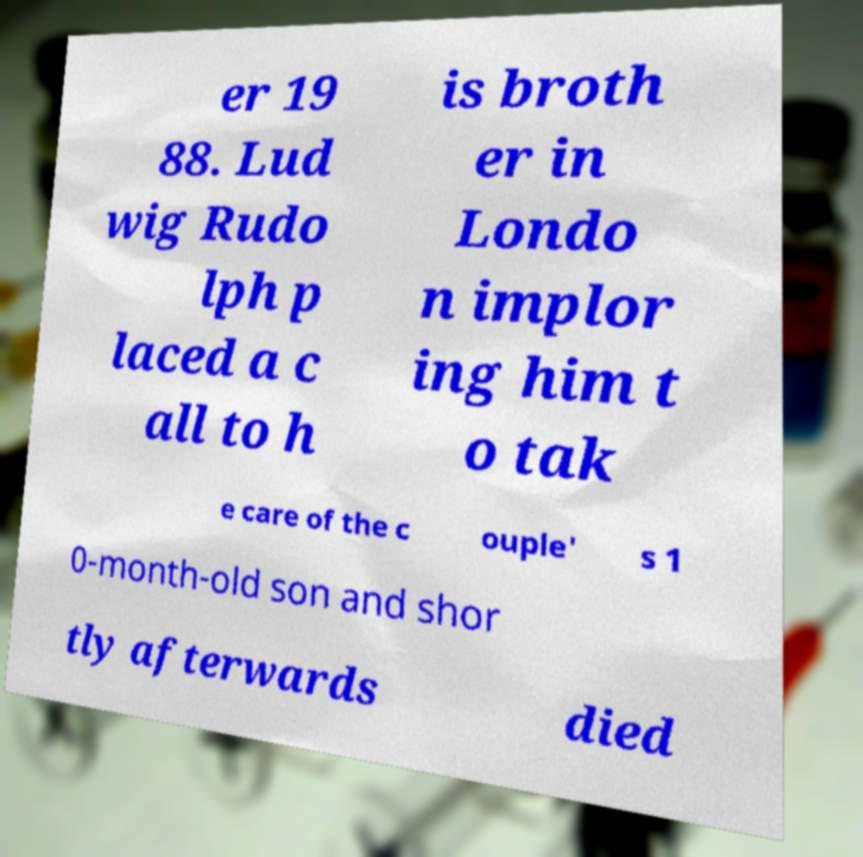Can you accurately transcribe the text from the provided image for me? er 19 88. Lud wig Rudo lph p laced a c all to h is broth er in Londo n implor ing him t o tak e care of the c ouple' s 1 0-month-old son and shor tly afterwards died 